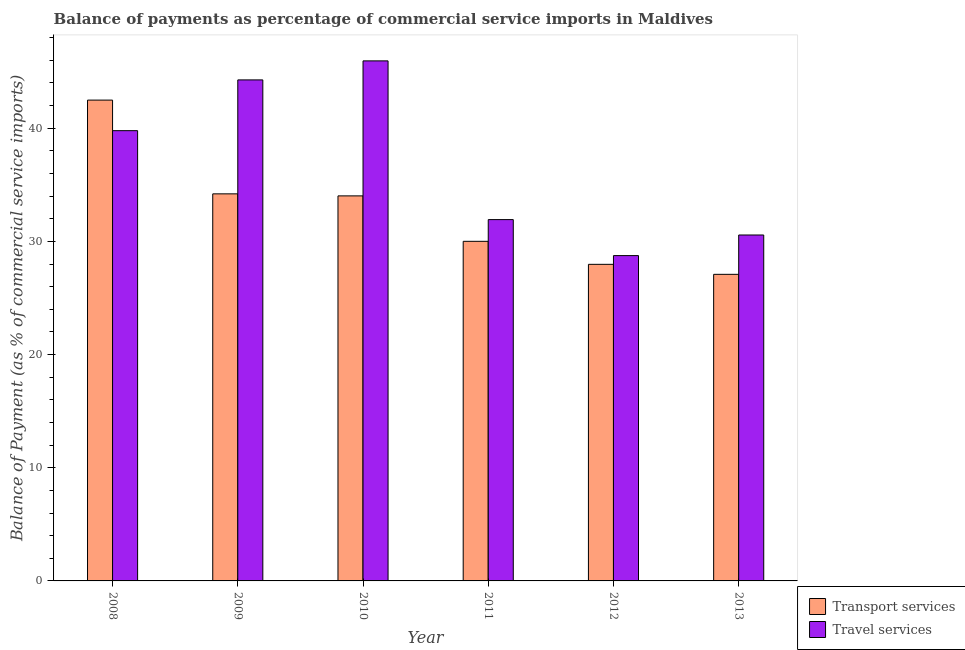How many different coloured bars are there?
Give a very brief answer. 2. How many groups of bars are there?
Your answer should be compact. 6. How many bars are there on the 4th tick from the left?
Provide a succinct answer. 2. How many bars are there on the 5th tick from the right?
Your answer should be compact. 2. What is the balance of payments of transport services in 2012?
Make the answer very short. 27.97. Across all years, what is the maximum balance of payments of transport services?
Ensure brevity in your answer.  42.48. Across all years, what is the minimum balance of payments of travel services?
Provide a succinct answer. 28.74. What is the total balance of payments of travel services in the graph?
Keep it short and to the point. 221.22. What is the difference between the balance of payments of travel services in 2008 and that in 2012?
Your response must be concise. 11.04. What is the difference between the balance of payments of transport services in 2013 and the balance of payments of travel services in 2011?
Ensure brevity in your answer.  -2.92. What is the average balance of payments of travel services per year?
Your response must be concise. 36.87. In how many years, is the balance of payments of transport services greater than 26 %?
Keep it short and to the point. 6. What is the ratio of the balance of payments of travel services in 2009 to that in 2010?
Make the answer very short. 0.96. Is the difference between the balance of payments of travel services in 2011 and 2013 greater than the difference between the balance of payments of transport services in 2011 and 2013?
Ensure brevity in your answer.  No. What is the difference between the highest and the second highest balance of payments of travel services?
Offer a terse response. 1.68. What is the difference between the highest and the lowest balance of payments of transport services?
Offer a terse response. 15.39. In how many years, is the balance of payments of travel services greater than the average balance of payments of travel services taken over all years?
Give a very brief answer. 3. Is the sum of the balance of payments of travel services in 2009 and 2013 greater than the maximum balance of payments of transport services across all years?
Give a very brief answer. Yes. What does the 2nd bar from the left in 2009 represents?
Your answer should be very brief. Travel services. What does the 2nd bar from the right in 2010 represents?
Offer a very short reply. Transport services. How many bars are there?
Your answer should be very brief. 12. Are all the bars in the graph horizontal?
Make the answer very short. No. Are the values on the major ticks of Y-axis written in scientific E-notation?
Your response must be concise. No. Where does the legend appear in the graph?
Give a very brief answer. Bottom right. What is the title of the graph?
Keep it short and to the point. Balance of payments as percentage of commercial service imports in Maldives. Does "Measles" appear as one of the legend labels in the graph?
Offer a very short reply. No. What is the label or title of the X-axis?
Your response must be concise. Year. What is the label or title of the Y-axis?
Your answer should be compact. Balance of Payment (as % of commercial service imports). What is the Balance of Payment (as % of commercial service imports) of Transport services in 2008?
Your answer should be very brief. 42.48. What is the Balance of Payment (as % of commercial service imports) in Travel services in 2008?
Provide a succinct answer. 39.78. What is the Balance of Payment (as % of commercial service imports) of Transport services in 2009?
Your answer should be very brief. 34.2. What is the Balance of Payment (as % of commercial service imports) in Travel services in 2009?
Your answer should be compact. 44.27. What is the Balance of Payment (as % of commercial service imports) in Transport services in 2010?
Your response must be concise. 34.02. What is the Balance of Payment (as % of commercial service imports) in Travel services in 2010?
Offer a terse response. 45.95. What is the Balance of Payment (as % of commercial service imports) of Transport services in 2011?
Ensure brevity in your answer.  30. What is the Balance of Payment (as % of commercial service imports) in Travel services in 2011?
Keep it short and to the point. 31.92. What is the Balance of Payment (as % of commercial service imports) in Transport services in 2012?
Your answer should be compact. 27.97. What is the Balance of Payment (as % of commercial service imports) of Travel services in 2012?
Give a very brief answer. 28.74. What is the Balance of Payment (as % of commercial service imports) in Transport services in 2013?
Offer a terse response. 27.09. What is the Balance of Payment (as % of commercial service imports) in Travel services in 2013?
Provide a short and direct response. 30.56. Across all years, what is the maximum Balance of Payment (as % of commercial service imports) in Transport services?
Give a very brief answer. 42.48. Across all years, what is the maximum Balance of Payment (as % of commercial service imports) in Travel services?
Make the answer very short. 45.95. Across all years, what is the minimum Balance of Payment (as % of commercial service imports) of Transport services?
Offer a terse response. 27.09. Across all years, what is the minimum Balance of Payment (as % of commercial service imports) in Travel services?
Ensure brevity in your answer.  28.74. What is the total Balance of Payment (as % of commercial service imports) in Transport services in the graph?
Your response must be concise. 195.76. What is the total Balance of Payment (as % of commercial service imports) of Travel services in the graph?
Your answer should be compact. 221.22. What is the difference between the Balance of Payment (as % of commercial service imports) in Transport services in 2008 and that in 2009?
Your answer should be very brief. 8.28. What is the difference between the Balance of Payment (as % of commercial service imports) of Travel services in 2008 and that in 2009?
Offer a terse response. -4.49. What is the difference between the Balance of Payment (as % of commercial service imports) of Transport services in 2008 and that in 2010?
Your response must be concise. 8.46. What is the difference between the Balance of Payment (as % of commercial service imports) of Travel services in 2008 and that in 2010?
Your answer should be very brief. -6.17. What is the difference between the Balance of Payment (as % of commercial service imports) in Transport services in 2008 and that in 2011?
Offer a terse response. 12.48. What is the difference between the Balance of Payment (as % of commercial service imports) of Travel services in 2008 and that in 2011?
Your answer should be compact. 7.86. What is the difference between the Balance of Payment (as % of commercial service imports) of Transport services in 2008 and that in 2012?
Ensure brevity in your answer.  14.51. What is the difference between the Balance of Payment (as % of commercial service imports) in Travel services in 2008 and that in 2012?
Give a very brief answer. 11.04. What is the difference between the Balance of Payment (as % of commercial service imports) of Transport services in 2008 and that in 2013?
Your response must be concise. 15.39. What is the difference between the Balance of Payment (as % of commercial service imports) of Travel services in 2008 and that in 2013?
Your response must be concise. 9.22. What is the difference between the Balance of Payment (as % of commercial service imports) in Transport services in 2009 and that in 2010?
Provide a succinct answer. 0.18. What is the difference between the Balance of Payment (as % of commercial service imports) of Travel services in 2009 and that in 2010?
Ensure brevity in your answer.  -1.68. What is the difference between the Balance of Payment (as % of commercial service imports) of Transport services in 2009 and that in 2011?
Your answer should be very brief. 4.19. What is the difference between the Balance of Payment (as % of commercial service imports) of Travel services in 2009 and that in 2011?
Provide a succinct answer. 12.34. What is the difference between the Balance of Payment (as % of commercial service imports) in Transport services in 2009 and that in 2012?
Offer a terse response. 6.23. What is the difference between the Balance of Payment (as % of commercial service imports) of Travel services in 2009 and that in 2012?
Ensure brevity in your answer.  15.52. What is the difference between the Balance of Payment (as % of commercial service imports) of Transport services in 2009 and that in 2013?
Ensure brevity in your answer.  7.11. What is the difference between the Balance of Payment (as % of commercial service imports) of Travel services in 2009 and that in 2013?
Give a very brief answer. 13.7. What is the difference between the Balance of Payment (as % of commercial service imports) in Transport services in 2010 and that in 2011?
Keep it short and to the point. 4.01. What is the difference between the Balance of Payment (as % of commercial service imports) of Travel services in 2010 and that in 2011?
Provide a short and direct response. 14.02. What is the difference between the Balance of Payment (as % of commercial service imports) of Transport services in 2010 and that in 2012?
Keep it short and to the point. 6.05. What is the difference between the Balance of Payment (as % of commercial service imports) in Travel services in 2010 and that in 2012?
Make the answer very short. 17.2. What is the difference between the Balance of Payment (as % of commercial service imports) of Transport services in 2010 and that in 2013?
Give a very brief answer. 6.93. What is the difference between the Balance of Payment (as % of commercial service imports) in Travel services in 2010 and that in 2013?
Keep it short and to the point. 15.38. What is the difference between the Balance of Payment (as % of commercial service imports) in Transport services in 2011 and that in 2012?
Offer a very short reply. 2.03. What is the difference between the Balance of Payment (as % of commercial service imports) of Travel services in 2011 and that in 2012?
Ensure brevity in your answer.  3.18. What is the difference between the Balance of Payment (as % of commercial service imports) in Transport services in 2011 and that in 2013?
Your answer should be very brief. 2.92. What is the difference between the Balance of Payment (as % of commercial service imports) in Travel services in 2011 and that in 2013?
Offer a terse response. 1.36. What is the difference between the Balance of Payment (as % of commercial service imports) in Transport services in 2012 and that in 2013?
Provide a succinct answer. 0.88. What is the difference between the Balance of Payment (as % of commercial service imports) of Travel services in 2012 and that in 2013?
Your answer should be compact. -1.82. What is the difference between the Balance of Payment (as % of commercial service imports) of Transport services in 2008 and the Balance of Payment (as % of commercial service imports) of Travel services in 2009?
Ensure brevity in your answer.  -1.78. What is the difference between the Balance of Payment (as % of commercial service imports) in Transport services in 2008 and the Balance of Payment (as % of commercial service imports) in Travel services in 2010?
Keep it short and to the point. -3.47. What is the difference between the Balance of Payment (as % of commercial service imports) of Transport services in 2008 and the Balance of Payment (as % of commercial service imports) of Travel services in 2011?
Your answer should be compact. 10.56. What is the difference between the Balance of Payment (as % of commercial service imports) of Transport services in 2008 and the Balance of Payment (as % of commercial service imports) of Travel services in 2012?
Offer a very short reply. 13.74. What is the difference between the Balance of Payment (as % of commercial service imports) in Transport services in 2008 and the Balance of Payment (as % of commercial service imports) in Travel services in 2013?
Provide a succinct answer. 11.92. What is the difference between the Balance of Payment (as % of commercial service imports) in Transport services in 2009 and the Balance of Payment (as % of commercial service imports) in Travel services in 2010?
Offer a very short reply. -11.75. What is the difference between the Balance of Payment (as % of commercial service imports) of Transport services in 2009 and the Balance of Payment (as % of commercial service imports) of Travel services in 2011?
Offer a terse response. 2.28. What is the difference between the Balance of Payment (as % of commercial service imports) of Transport services in 2009 and the Balance of Payment (as % of commercial service imports) of Travel services in 2012?
Provide a short and direct response. 5.46. What is the difference between the Balance of Payment (as % of commercial service imports) in Transport services in 2009 and the Balance of Payment (as % of commercial service imports) in Travel services in 2013?
Your answer should be compact. 3.64. What is the difference between the Balance of Payment (as % of commercial service imports) of Transport services in 2010 and the Balance of Payment (as % of commercial service imports) of Travel services in 2011?
Offer a very short reply. 2.1. What is the difference between the Balance of Payment (as % of commercial service imports) of Transport services in 2010 and the Balance of Payment (as % of commercial service imports) of Travel services in 2012?
Make the answer very short. 5.28. What is the difference between the Balance of Payment (as % of commercial service imports) in Transport services in 2010 and the Balance of Payment (as % of commercial service imports) in Travel services in 2013?
Offer a very short reply. 3.46. What is the difference between the Balance of Payment (as % of commercial service imports) in Transport services in 2011 and the Balance of Payment (as % of commercial service imports) in Travel services in 2012?
Offer a terse response. 1.26. What is the difference between the Balance of Payment (as % of commercial service imports) in Transport services in 2011 and the Balance of Payment (as % of commercial service imports) in Travel services in 2013?
Provide a short and direct response. -0.56. What is the difference between the Balance of Payment (as % of commercial service imports) in Transport services in 2012 and the Balance of Payment (as % of commercial service imports) in Travel services in 2013?
Ensure brevity in your answer.  -2.59. What is the average Balance of Payment (as % of commercial service imports) of Transport services per year?
Offer a terse response. 32.63. What is the average Balance of Payment (as % of commercial service imports) in Travel services per year?
Your response must be concise. 36.87. In the year 2008, what is the difference between the Balance of Payment (as % of commercial service imports) in Transport services and Balance of Payment (as % of commercial service imports) in Travel services?
Keep it short and to the point. 2.7. In the year 2009, what is the difference between the Balance of Payment (as % of commercial service imports) of Transport services and Balance of Payment (as % of commercial service imports) of Travel services?
Your response must be concise. -10.07. In the year 2010, what is the difference between the Balance of Payment (as % of commercial service imports) of Transport services and Balance of Payment (as % of commercial service imports) of Travel services?
Offer a terse response. -11.93. In the year 2011, what is the difference between the Balance of Payment (as % of commercial service imports) in Transport services and Balance of Payment (as % of commercial service imports) in Travel services?
Offer a terse response. -1.92. In the year 2012, what is the difference between the Balance of Payment (as % of commercial service imports) of Transport services and Balance of Payment (as % of commercial service imports) of Travel services?
Offer a very short reply. -0.77. In the year 2013, what is the difference between the Balance of Payment (as % of commercial service imports) in Transport services and Balance of Payment (as % of commercial service imports) in Travel services?
Offer a terse response. -3.48. What is the ratio of the Balance of Payment (as % of commercial service imports) in Transport services in 2008 to that in 2009?
Provide a short and direct response. 1.24. What is the ratio of the Balance of Payment (as % of commercial service imports) of Travel services in 2008 to that in 2009?
Offer a very short reply. 0.9. What is the ratio of the Balance of Payment (as % of commercial service imports) in Transport services in 2008 to that in 2010?
Offer a very short reply. 1.25. What is the ratio of the Balance of Payment (as % of commercial service imports) of Travel services in 2008 to that in 2010?
Ensure brevity in your answer.  0.87. What is the ratio of the Balance of Payment (as % of commercial service imports) in Transport services in 2008 to that in 2011?
Offer a very short reply. 1.42. What is the ratio of the Balance of Payment (as % of commercial service imports) of Travel services in 2008 to that in 2011?
Make the answer very short. 1.25. What is the ratio of the Balance of Payment (as % of commercial service imports) of Transport services in 2008 to that in 2012?
Provide a short and direct response. 1.52. What is the ratio of the Balance of Payment (as % of commercial service imports) in Travel services in 2008 to that in 2012?
Offer a terse response. 1.38. What is the ratio of the Balance of Payment (as % of commercial service imports) in Transport services in 2008 to that in 2013?
Offer a terse response. 1.57. What is the ratio of the Balance of Payment (as % of commercial service imports) of Travel services in 2008 to that in 2013?
Your answer should be very brief. 1.3. What is the ratio of the Balance of Payment (as % of commercial service imports) of Transport services in 2009 to that in 2010?
Offer a very short reply. 1.01. What is the ratio of the Balance of Payment (as % of commercial service imports) of Travel services in 2009 to that in 2010?
Give a very brief answer. 0.96. What is the ratio of the Balance of Payment (as % of commercial service imports) in Transport services in 2009 to that in 2011?
Offer a terse response. 1.14. What is the ratio of the Balance of Payment (as % of commercial service imports) of Travel services in 2009 to that in 2011?
Your response must be concise. 1.39. What is the ratio of the Balance of Payment (as % of commercial service imports) of Transport services in 2009 to that in 2012?
Give a very brief answer. 1.22. What is the ratio of the Balance of Payment (as % of commercial service imports) in Travel services in 2009 to that in 2012?
Keep it short and to the point. 1.54. What is the ratio of the Balance of Payment (as % of commercial service imports) in Transport services in 2009 to that in 2013?
Ensure brevity in your answer.  1.26. What is the ratio of the Balance of Payment (as % of commercial service imports) of Travel services in 2009 to that in 2013?
Ensure brevity in your answer.  1.45. What is the ratio of the Balance of Payment (as % of commercial service imports) of Transport services in 2010 to that in 2011?
Provide a short and direct response. 1.13. What is the ratio of the Balance of Payment (as % of commercial service imports) of Travel services in 2010 to that in 2011?
Offer a terse response. 1.44. What is the ratio of the Balance of Payment (as % of commercial service imports) of Transport services in 2010 to that in 2012?
Make the answer very short. 1.22. What is the ratio of the Balance of Payment (as % of commercial service imports) in Travel services in 2010 to that in 2012?
Ensure brevity in your answer.  1.6. What is the ratio of the Balance of Payment (as % of commercial service imports) of Transport services in 2010 to that in 2013?
Offer a terse response. 1.26. What is the ratio of the Balance of Payment (as % of commercial service imports) of Travel services in 2010 to that in 2013?
Your answer should be very brief. 1.5. What is the ratio of the Balance of Payment (as % of commercial service imports) in Transport services in 2011 to that in 2012?
Make the answer very short. 1.07. What is the ratio of the Balance of Payment (as % of commercial service imports) of Travel services in 2011 to that in 2012?
Give a very brief answer. 1.11. What is the ratio of the Balance of Payment (as % of commercial service imports) of Transport services in 2011 to that in 2013?
Ensure brevity in your answer.  1.11. What is the ratio of the Balance of Payment (as % of commercial service imports) of Travel services in 2011 to that in 2013?
Provide a succinct answer. 1.04. What is the ratio of the Balance of Payment (as % of commercial service imports) of Transport services in 2012 to that in 2013?
Provide a short and direct response. 1.03. What is the ratio of the Balance of Payment (as % of commercial service imports) in Travel services in 2012 to that in 2013?
Ensure brevity in your answer.  0.94. What is the difference between the highest and the second highest Balance of Payment (as % of commercial service imports) of Transport services?
Give a very brief answer. 8.28. What is the difference between the highest and the second highest Balance of Payment (as % of commercial service imports) in Travel services?
Your answer should be very brief. 1.68. What is the difference between the highest and the lowest Balance of Payment (as % of commercial service imports) in Transport services?
Your answer should be very brief. 15.39. What is the difference between the highest and the lowest Balance of Payment (as % of commercial service imports) of Travel services?
Provide a short and direct response. 17.2. 